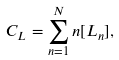<formula> <loc_0><loc_0><loc_500><loc_500>C _ { L } = \sum _ { n = 1 } ^ { N } n [ L _ { n } ] ,</formula> 